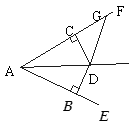Can you explain why triangle ADG uses a different method to compute its angles compared to triangles ADB and ADC? Triangle ADG's angle computations differ because ADG, unlike ADB and ADC, is not established by perpendicular lines or congruent segments. Its angles are determined using the sum of angles in a triangle (180°) and subtracting known angles to find the unknown, which varies from the symmetry used in ADB and ADC. 